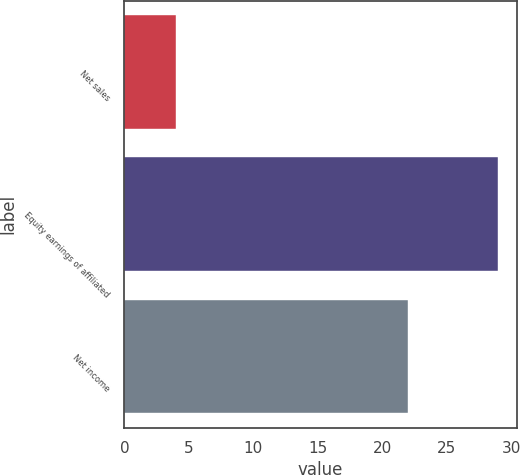Convert chart. <chart><loc_0><loc_0><loc_500><loc_500><bar_chart><fcel>Net sales<fcel>Equity earnings of affiliated<fcel>Net income<nl><fcel>4<fcel>29<fcel>22<nl></chart> 